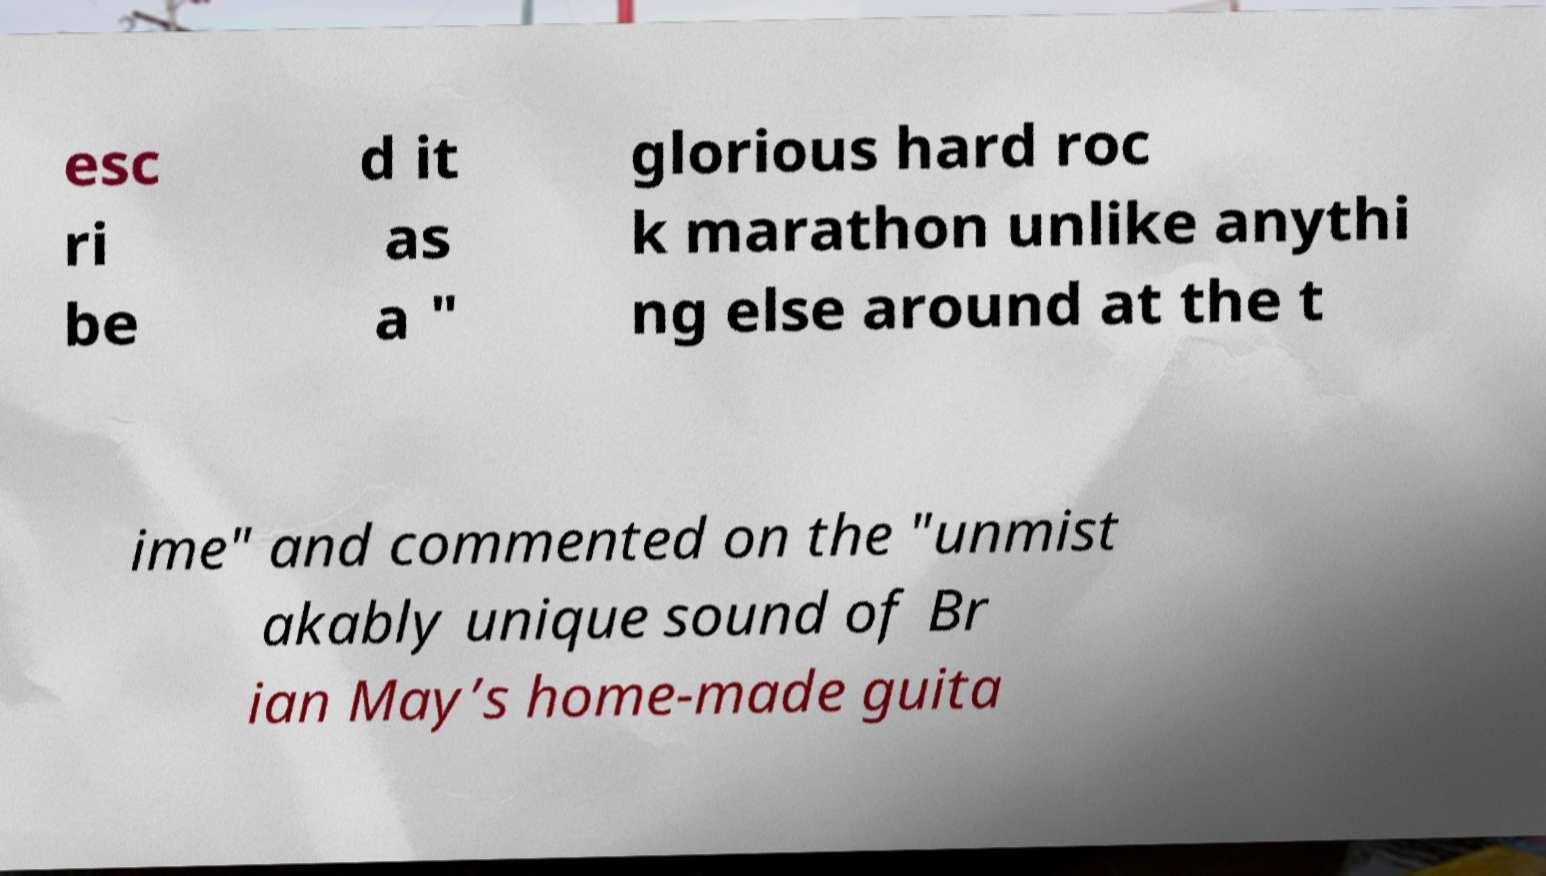Could you assist in decoding the text presented in this image and type it out clearly? esc ri be d it as a " glorious hard roc k marathon unlike anythi ng else around at the t ime" and commented on the "unmist akably unique sound of Br ian May’s home-made guita 